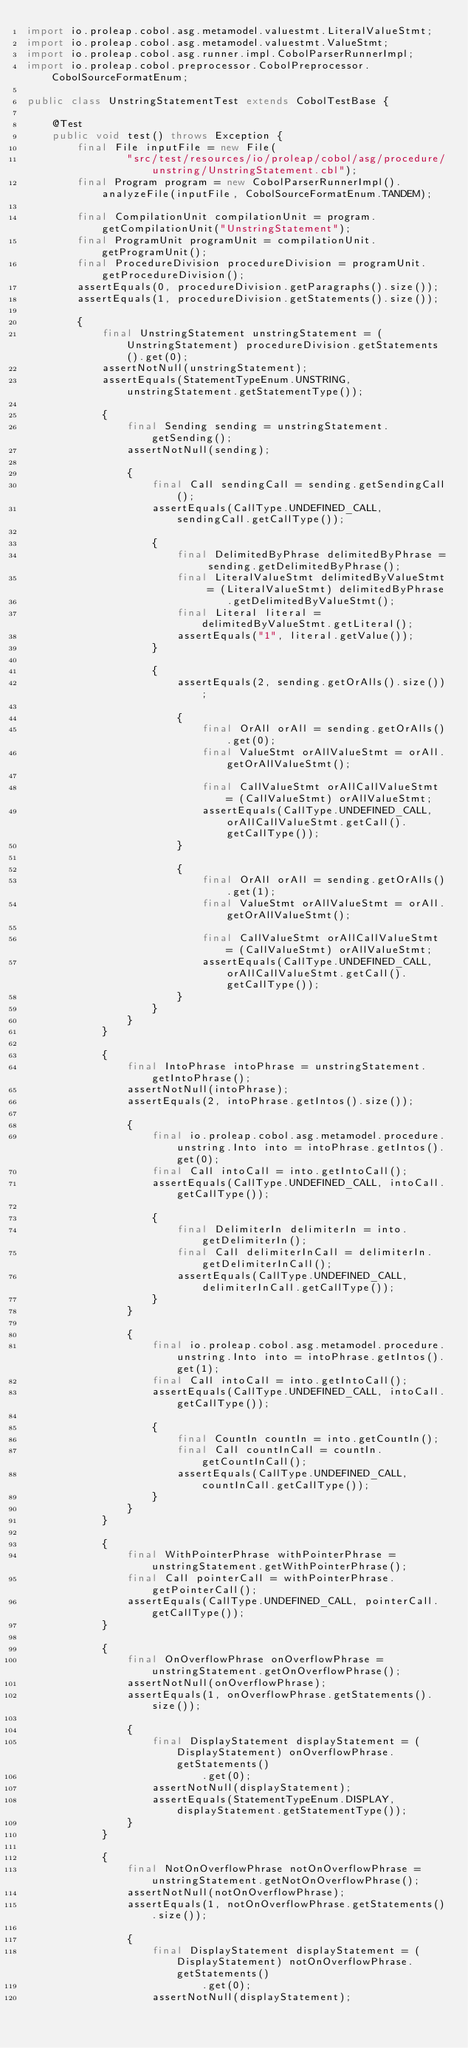<code> <loc_0><loc_0><loc_500><loc_500><_Java_>import io.proleap.cobol.asg.metamodel.valuestmt.LiteralValueStmt;
import io.proleap.cobol.asg.metamodel.valuestmt.ValueStmt;
import io.proleap.cobol.asg.runner.impl.CobolParserRunnerImpl;
import io.proleap.cobol.preprocessor.CobolPreprocessor.CobolSourceFormatEnum;

public class UnstringStatementTest extends CobolTestBase {

	@Test
	public void test() throws Exception {
		final File inputFile = new File(
				"src/test/resources/io/proleap/cobol/asg/procedure/unstring/UnstringStatement.cbl");
		final Program program = new CobolParserRunnerImpl().analyzeFile(inputFile, CobolSourceFormatEnum.TANDEM);

		final CompilationUnit compilationUnit = program.getCompilationUnit("UnstringStatement");
		final ProgramUnit programUnit = compilationUnit.getProgramUnit();
		final ProcedureDivision procedureDivision = programUnit.getProcedureDivision();
		assertEquals(0, procedureDivision.getParagraphs().size());
		assertEquals(1, procedureDivision.getStatements().size());

		{
			final UnstringStatement unstringStatement = (UnstringStatement) procedureDivision.getStatements().get(0);
			assertNotNull(unstringStatement);
			assertEquals(StatementTypeEnum.UNSTRING, unstringStatement.getStatementType());

			{
				final Sending sending = unstringStatement.getSending();
				assertNotNull(sending);

				{
					final Call sendingCall = sending.getSendingCall();
					assertEquals(CallType.UNDEFINED_CALL, sendingCall.getCallType());

					{
						final DelimitedByPhrase delimitedByPhrase = sending.getDelimitedByPhrase();
						final LiteralValueStmt delimitedByValueStmt = (LiteralValueStmt) delimitedByPhrase
								.getDelimitedByValueStmt();
						final Literal literal = delimitedByValueStmt.getLiteral();
						assertEquals("1", literal.getValue());
					}

					{
						assertEquals(2, sending.getOrAlls().size());

						{
							final OrAll orAll = sending.getOrAlls().get(0);
							final ValueStmt orAllValueStmt = orAll.getOrAllValueStmt();

							final CallValueStmt orAllCallValueStmt = (CallValueStmt) orAllValueStmt;
							assertEquals(CallType.UNDEFINED_CALL, orAllCallValueStmt.getCall().getCallType());
						}

						{
							final OrAll orAll = sending.getOrAlls().get(1);
							final ValueStmt orAllValueStmt = orAll.getOrAllValueStmt();

							final CallValueStmt orAllCallValueStmt = (CallValueStmt) orAllValueStmt;
							assertEquals(CallType.UNDEFINED_CALL, orAllCallValueStmt.getCall().getCallType());
						}
					}
				}
			}

			{
				final IntoPhrase intoPhrase = unstringStatement.getIntoPhrase();
				assertNotNull(intoPhrase);
				assertEquals(2, intoPhrase.getIntos().size());

				{
					final io.proleap.cobol.asg.metamodel.procedure.unstring.Into into = intoPhrase.getIntos().get(0);
					final Call intoCall = into.getIntoCall();
					assertEquals(CallType.UNDEFINED_CALL, intoCall.getCallType());

					{
						final DelimiterIn delimiterIn = into.getDelimiterIn();
						final Call delimiterInCall = delimiterIn.getDelimiterInCall();
						assertEquals(CallType.UNDEFINED_CALL, delimiterInCall.getCallType());
					}
				}

				{
					final io.proleap.cobol.asg.metamodel.procedure.unstring.Into into = intoPhrase.getIntos().get(1);
					final Call intoCall = into.getIntoCall();
					assertEquals(CallType.UNDEFINED_CALL, intoCall.getCallType());

					{
						final CountIn countIn = into.getCountIn();
						final Call countInCall = countIn.getCountInCall();
						assertEquals(CallType.UNDEFINED_CALL, countInCall.getCallType());
					}
				}
			}

			{
				final WithPointerPhrase withPointerPhrase = unstringStatement.getWithPointerPhrase();
				final Call pointerCall = withPointerPhrase.getPointerCall();
				assertEquals(CallType.UNDEFINED_CALL, pointerCall.getCallType());
			}

			{
				final OnOverflowPhrase onOverflowPhrase = unstringStatement.getOnOverflowPhrase();
				assertNotNull(onOverflowPhrase);
				assertEquals(1, onOverflowPhrase.getStatements().size());

				{
					final DisplayStatement displayStatement = (DisplayStatement) onOverflowPhrase.getStatements()
							.get(0);
					assertNotNull(displayStatement);
					assertEquals(StatementTypeEnum.DISPLAY, displayStatement.getStatementType());
				}
			}

			{
				final NotOnOverflowPhrase notOnOverflowPhrase = unstringStatement.getNotOnOverflowPhrase();
				assertNotNull(notOnOverflowPhrase);
				assertEquals(1, notOnOverflowPhrase.getStatements().size());

				{
					final DisplayStatement displayStatement = (DisplayStatement) notOnOverflowPhrase.getStatements()
							.get(0);
					assertNotNull(displayStatement);</code> 